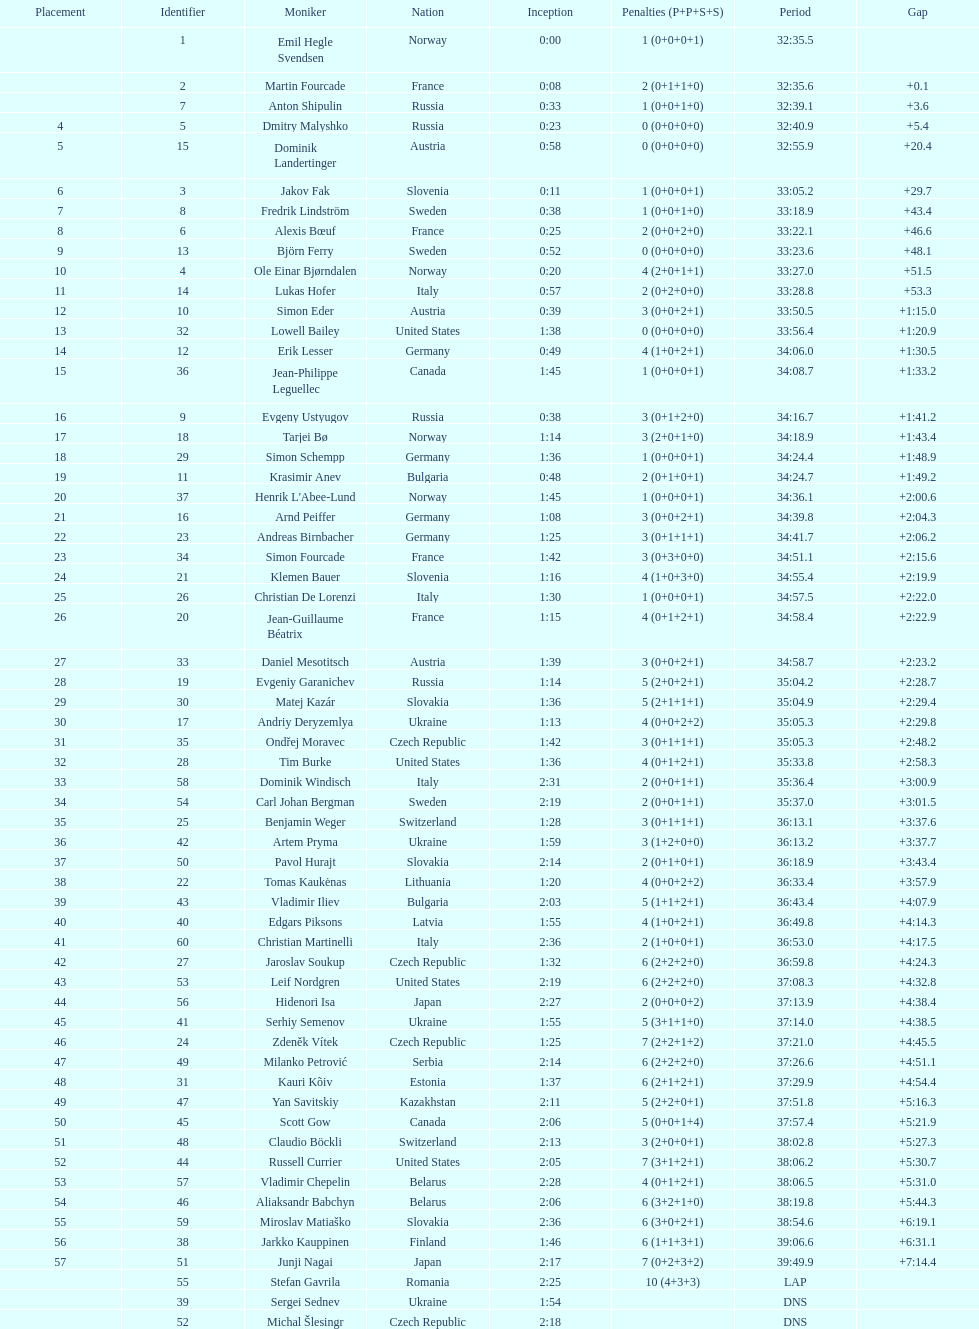Who is the top ranked runner of sweden? Fredrik Lindström. 